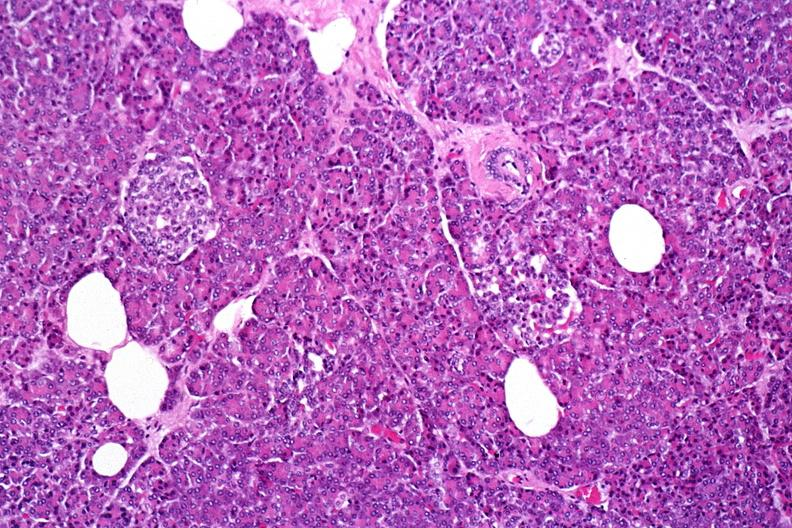does this image show normal pancreas?
Answer the question using a single word or phrase. Yes 